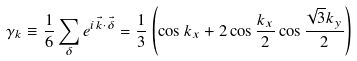<formula> <loc_0><loc_0><loc_500><loc_500>\gamma _ { k } \equiv \frac { 1 } { 6 } \sum _ { \delta } { e ^ { i \vec { k } \cdot \vec { \delta } } } = \frac { 1 } { 3 } \left ( \cos { k _ { x } } + 2 \cos { \frac { k _ { x } } { 2 } } \cos { \frac { \sqrt { 3 } k _ { y } } { 2 } } \right )</formula> 